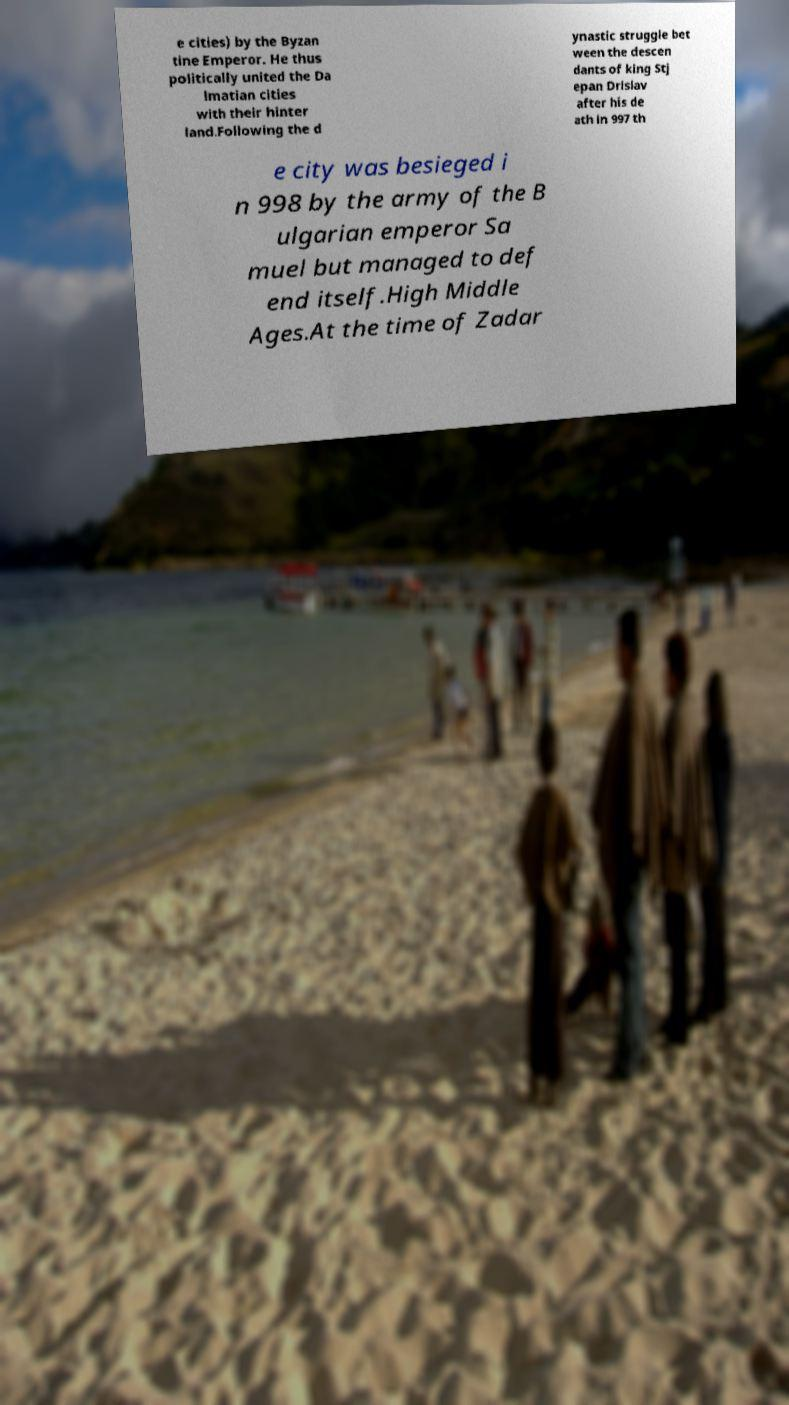What messages or text are displayed in this image? I need them in a readable, typed format. e cities) by the Byzan tine Emperor. He thus politically united the Da lmatian cities with their hinter land.Following the d ynastic struggle bet ween the descen dants of king Stj epan Drislav after his de ath in 997 th e city was besieged i n 998 by the army of the B ulgarian emperor Sa muel but managed to def end itself.High Middle Ages.At the time of Zadar 